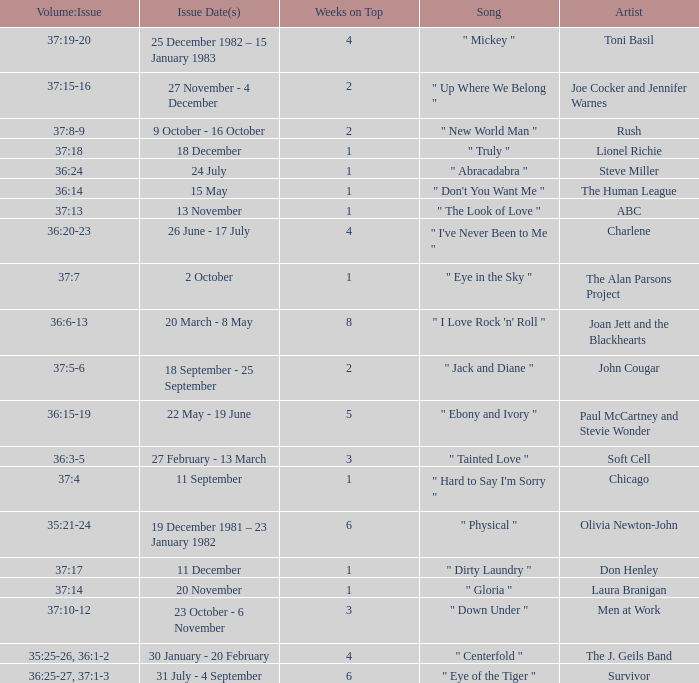Which Issue Date(s) has an Artist of men at work? 23 October - 6 November. 